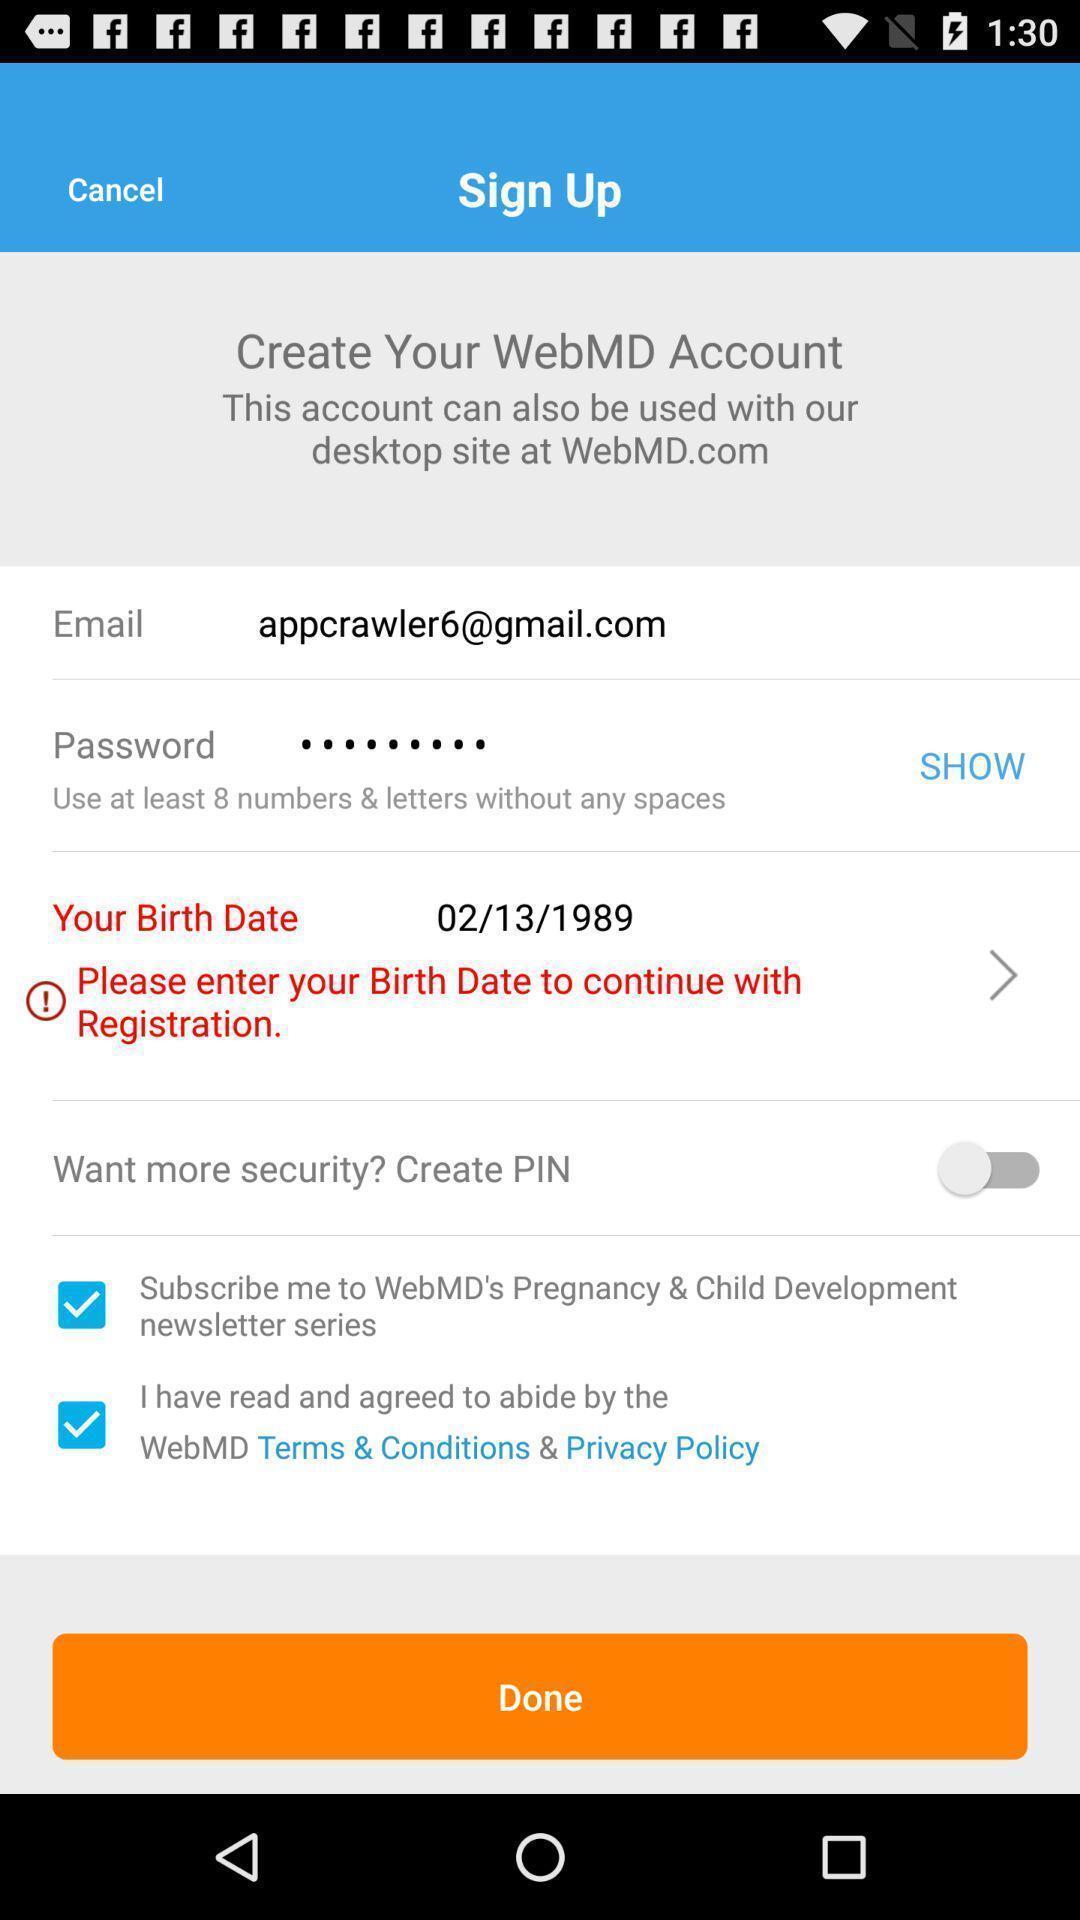What can you discern from this picture? Sign up page with text boxes to enter the credentials. 